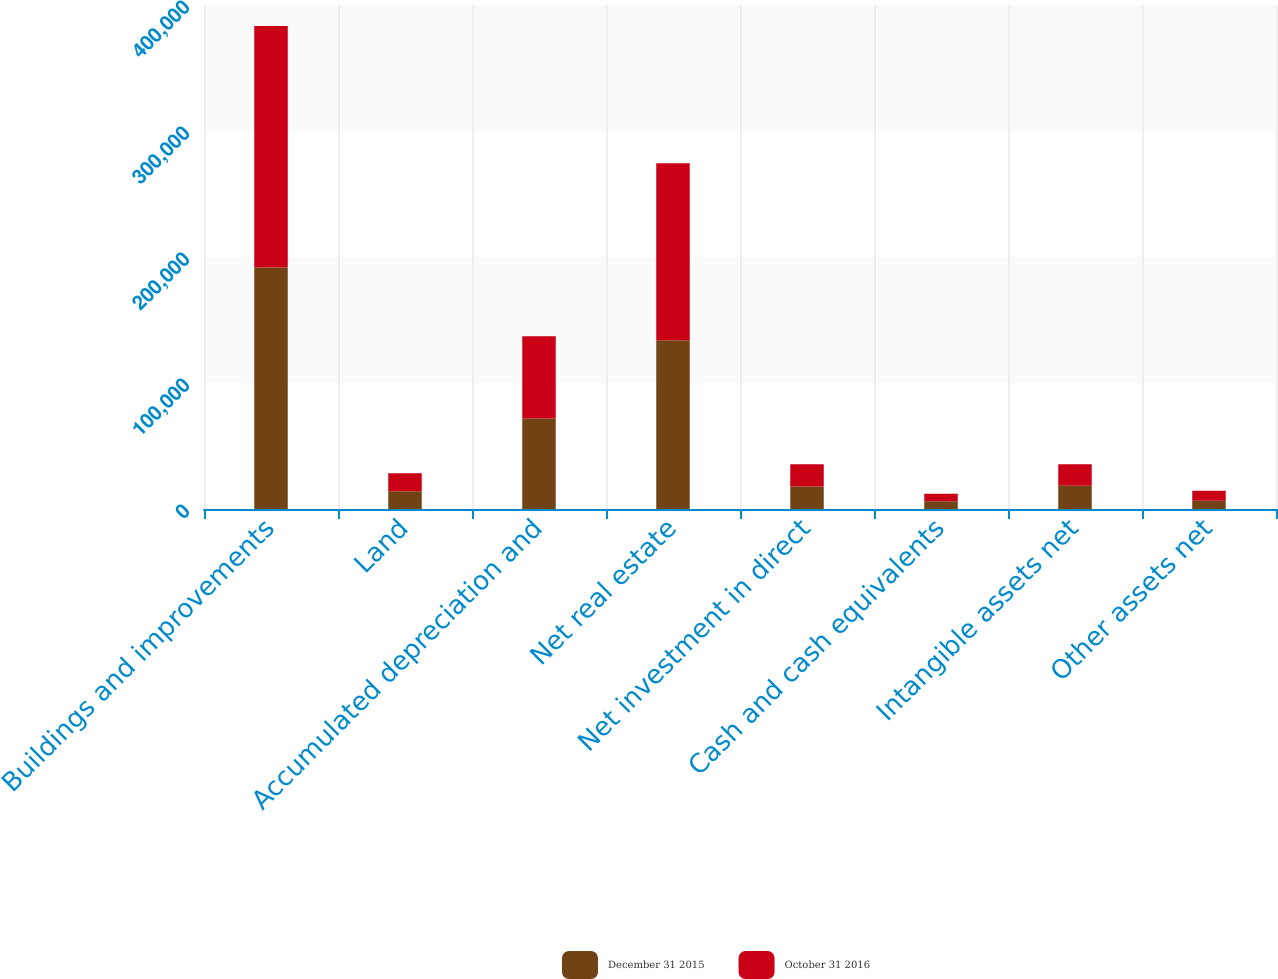Convert chart to OTSL. <chart><loc_0><loc_0><loc_500><loc_500><stacked_bar_chart><ecel><fcel>Buildings and improvements<fcel>Land<fcel>Accumulated depreciation and<fcel>Net real estate<fcel>Net investment in direct<fcel>Cash and cash equivalents<fcel>Intangible assets net<fcel>Other assets net<nl><fcel>December 31 2015<fcel>191633<fcel>14147<fcel>71845<fcel>133935<fcel>17783<fcel>6096<fcel>18517<fcel>6620<nl><fcel>October 31 2016<fcel>191633<fcel>14147<fcel>65319<fcel>140461<fcel>17783<fcel>6058<fcel>17049<fcel>7790<nl></chart> 